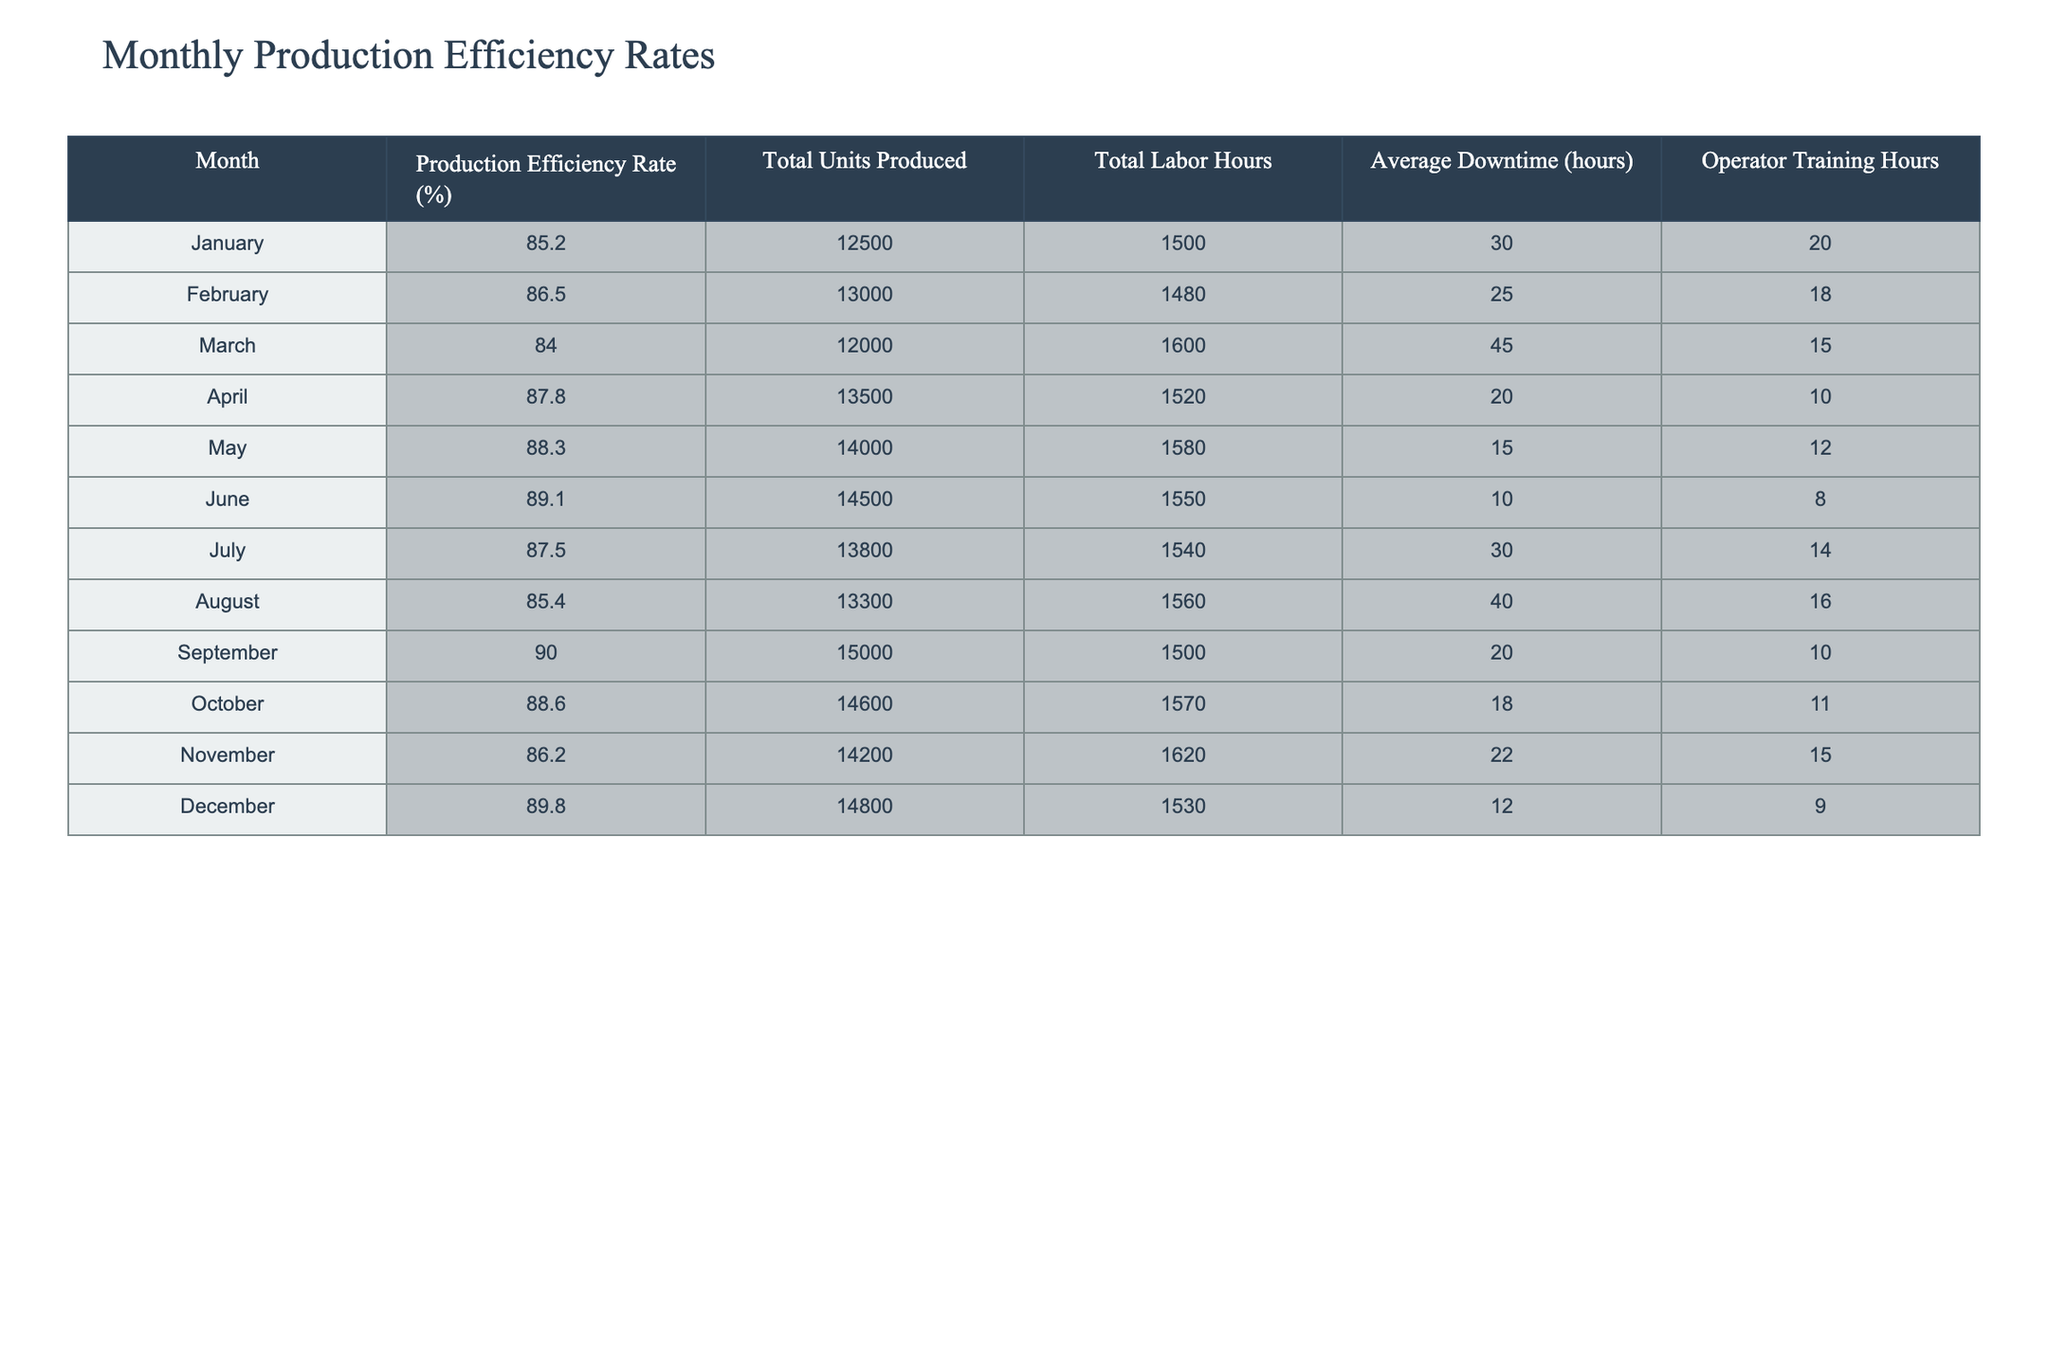What was the highest production efficiency rate recorded in the year? To find the highest production efficiency rate, we look through the "Production Efficiency Rate (%)" column. The highest value is 90.0%, which occurs in September.
Answer: 90.0% In which month was the total labor hours the lowest? By reviewing the "Total Labor Hours" column, we see the values for each month. January has 1500 hours, February has 1480 hours, March has 1600 hours, and so on. February has the lowest total labor hours at 1480.
Answer: February What is the average production efficiency rate for the first half of the year? We calculate the average of the production efficiency rates from January to June, which are 85.2, 86.5, 84.0, 87.8, 88.3, and 89.1. First, sum these values: 85.2 + 86.5 + 84.0 + 87.8 + 88.3 + 89.1 = 520.9. Then, divide by the number of months (6): 520.9 / 6 = 86.82.
Answer: 86.82 Did the average downtime decrease from January to June? We will compare the average downtime for January (30 hours), February (25 hours), March (45 hours), April (20 hours), May (15 hours), and June (10 hours). August has downtime of 40 hours, which is higher than average downtime in the first half of the year, so it did decrease.
Answer: Yes What was the total number of units produced in the second half of the year? We will sum the total units produced from July to December, which are 13800, 13300, 15000, 14600, 14200, and 14800. Adding these values gives 13800 + 13300 + 15000 + 14600 + 14200 + 14800 = 85700.
Answer: 85700 Which month had the highest average downtime? Looking at the “Average Downtime (hours)” column, we assess the values from January to December. March has 45 hours of downtime, making it the highest.
Answer: March What is the difference between the highest and lowest production efficiency rates for the year? We find the highest production efficiency rate is 90.0% (September) and the lowest is 84.0% (March). The difference is 90.0 - 84.0 = 6.0%.
Answer: 6.0% Which month had the most operator training hours? We analyze the "Operator Training Hours" column. The numbers are as follows: January (20), February (18), March (15), April (10), May (12), June (8), July (14), August (16), September (10), October (11), November (15), December (9). January has the highest training hours at 20.
Answer: January 